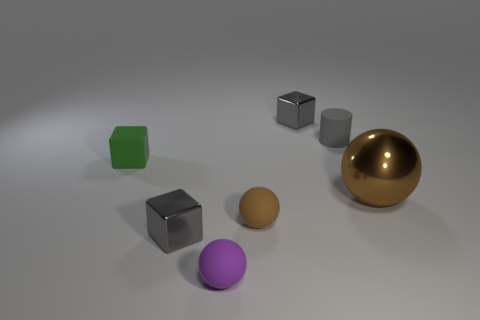Subtract all blue spheres. How many gray blocks are left? 2 Subtract all large brown metallic spheres. How many spheres are left? 2 Subtract 1 balls. How many balls are left? 2 Add 2 large brown metal balls. How many objects exist? 9 Subtract all cubes. How many objects are left? 4 Add 2 small gray blocks. How many small gray blocks exist? 4 Subtract 0 red cylinders. How many objects are left? 7 Subtract all tiny green spheres. Subtract all small brown balls. How many objects are left? 6 Add 7 brown metallic objects. How many brown metallic objects are left? 8 